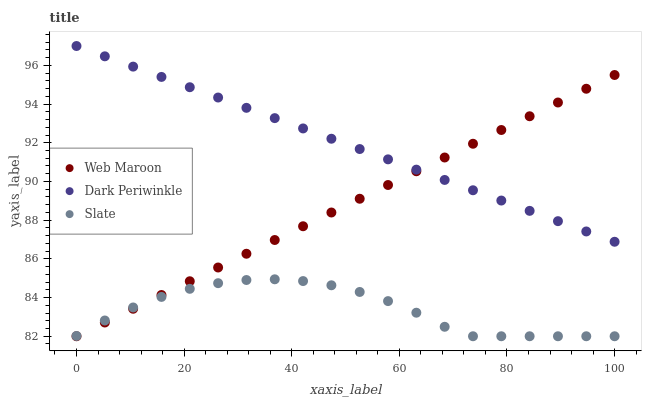Does Slate have the minimum area under the curve?
Answer yes or no. Yes. Does Dark Periwinkle have the maximum area under the curve?
Answer yes or no. Yes. Does Web Maroon have the minimum area under the curve?
Answer yes or no. No. Does Web Maroon have the maximum area under the curve?
Answer yes or no. No. Is Web Maroon the smoothest?
Answer yes or no. Yes. Is Slate the roughest?
Answer yes or no. Yes. Is Dark Periwinkle the smoothest?
Answer yes or no. No. Is Dark Periwinkle the roughest?
Answer yes or no. No. Does Slate have the lowest value?
Answer yes or no. Yes. Does Dark Periwinkle have the lowest value?
Answer yes or no. No. Does Dark Periwinkle have the highest value?
Answer yes or no. Yes. Does Web Maroon have the highest value?
Answer yes or no. No. Is Slate less than Dark Periwinkle?
Answer yes or no. Yes. Is Dark Periwinkle greater than Slate?
Answer yes or no. Yes. Does Dark Periwinkle intersect Web Maroon?
Answer yes or no. Yes. Is Dark Periwinkle less than Web Maroon?
Answer yes or no. No. Is Dark Periwinkle greater than Web Maroon?
Answer yes or no. No. Does Slate intersect Dark Periwinkle?
Answer yes or no. No. 